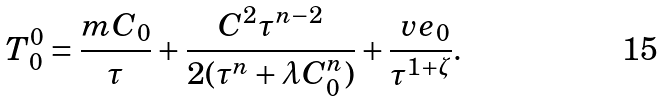<formula> <loc_0><loc_0><loc_500><loc_500>T _ { 0 } ^ { 0 } = \frac { m C _ { 0 } } { \tau } + \frac { C ^ { 2 } \tau ^ { n - 2 } } { 2 ( \tau ^ { n } + \lambda C _ { 0 } ^ { n } ) } + \frac { \ v e _ { 0 } } { \tau ^ { 1 + \zeta } } .</formula> 